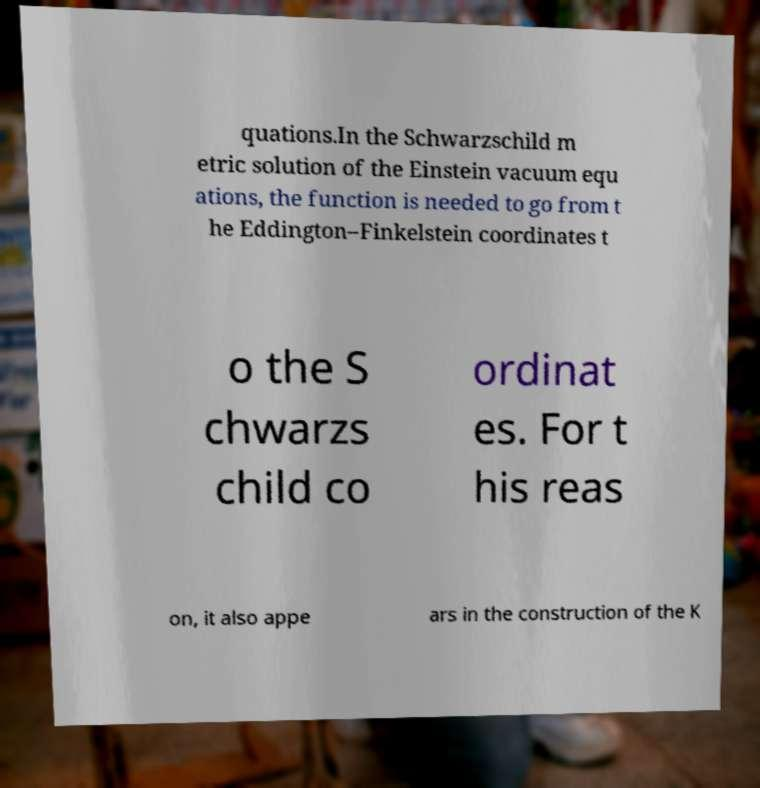Can you accurately transcribe the text from the provided image for me? quations.In the Schwarzschild m etric solution of the Einstein vacuum equ ations, the function is needed to go from t he Eddington–Finkelstein coordinates t o the S chwarzs child co ordinat es. For t his reas on, it also appe ars in the construction of the K 